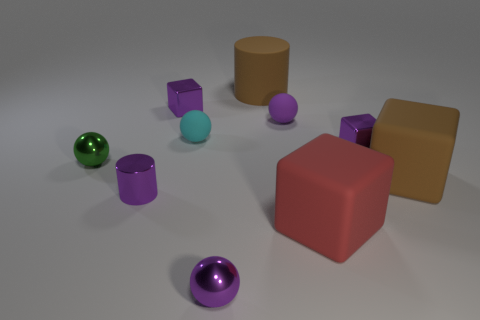Subtract all brown cubes. How many cubes are left? 3 Subtract all spheres. How many objects are left? 6 Subtract all green spheres. How many spheres are left? 3 Subtract 0 yellow cubes. How many objects are left? 10 Subtract 3 cubes. How many cubes are left? 1 Subtract all blue cylinders. Subtract all gray cubes. How many cylinders are left? 2 Subtract all gray blocks. How many cyan cylinders are left? 0 Subtract all blocks. Subtract all small purple shiny things. How many objects are left? 2 Add 6 tiny green metallic balls. How many tiny green metallic balls are left? 7 Add 2 purple things. How many purple things exist? 7 